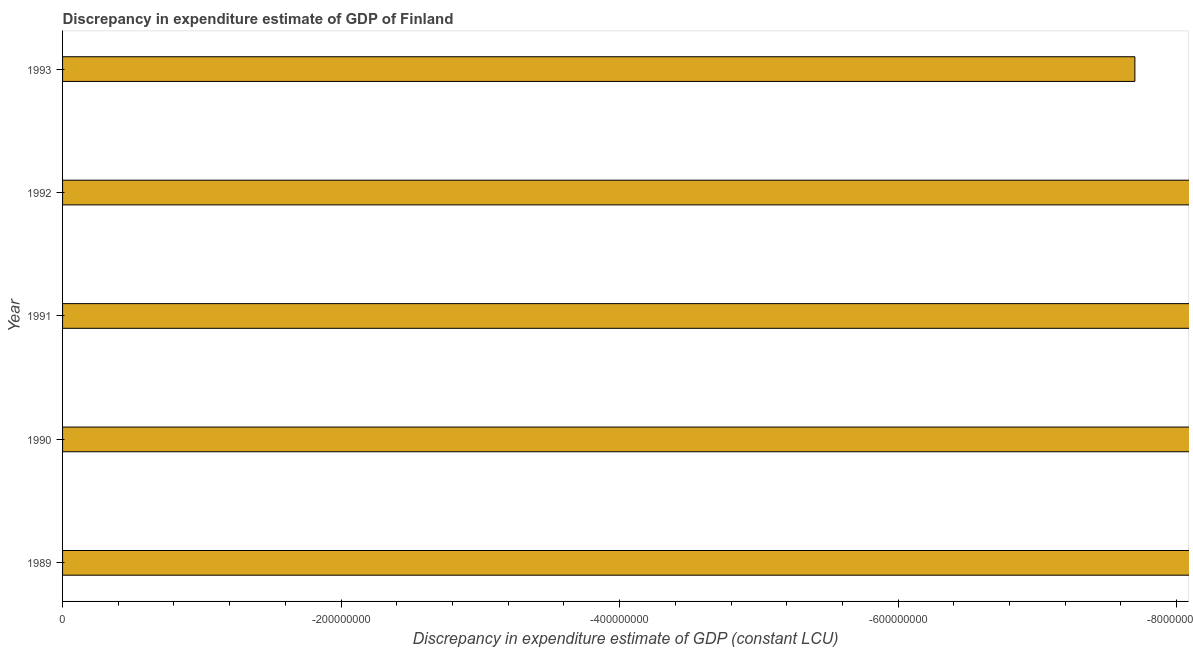What is the title of the graph?
Offer a very short reply. Discrepancy in expenditure estimate of GDP of Finland. What is the label or title of the X-axis?
Keep it short and to the point. Discrepancy in expenditure estimate of GDP (constant LCU). Across all years, what is the minimum discrepancy in expenditure estimate of gdp?
Give a very brief answer. 0. What is the average discrepancy in expenditure estimate of gdp per year?
Offer a terse response. 0. What is the median discrepancy in expenditure estimate of gdp?
Provide a succinct answer. 0. In how many years, is the discrepancy in expenditure estimate of gdp greater than -400000000 LCU?
Provide a short and direct response. 0. How many bars are there?
Ensure brevity in your answer.  0. Are all the bars in the graph horizontal?
Provide a succinct answer. Yes. How many years are there in the graph?
Keep it short and to the point. 5. What is the Discrepancy in expenditure estimate of GDP (constant LCU) in 1990?
Ensure brevity in your answer.  0. What is the Discrepancy in expenditure estimate of GDP (constant LCU) of 1991?
Ensure brevity in your answer.  0. What is the Discrepancy in expenditure estimate of GDP (constant LCU) in 1992?
Make the answer very short. 0. 